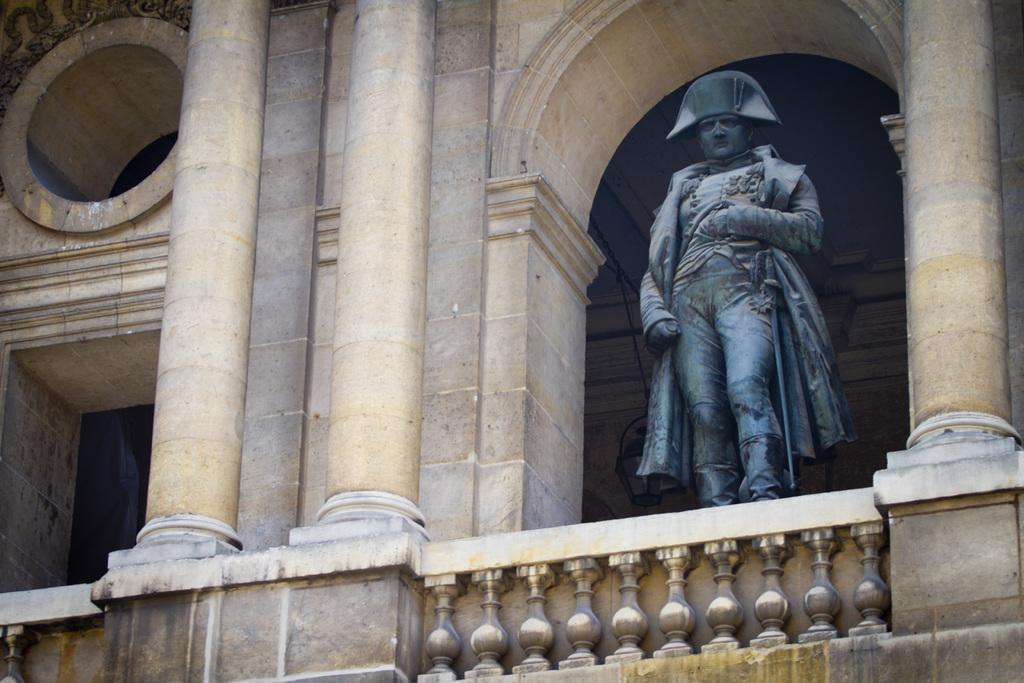What is the main subject in the image? There is a statue in the image. What architectural features can be seen in the image? There are pillars and a wall in the image. What is the purpose of the grill in the image? The grill in the image is likely used for cooking or barbecuing. What type of polish is being applied to the statue in the image? There is no indication in the image that any polish is being applied to the statue. 